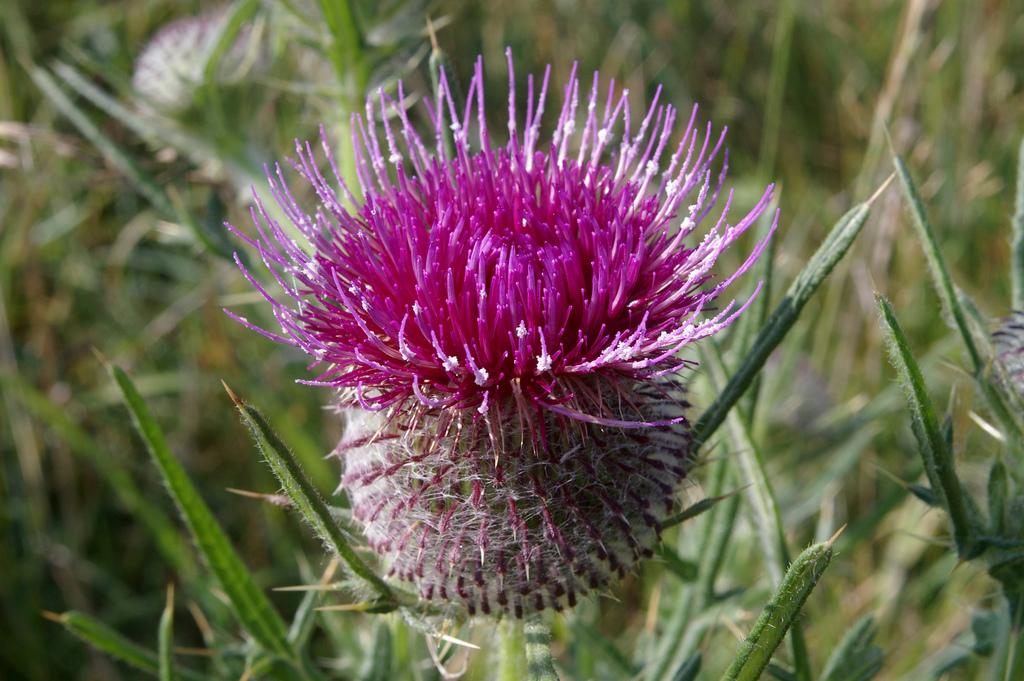What type of flower can be seen in the image? There is a pink color flower in the image. What stage of growth are the plants in the image at? There are buds on the plants in the image, indicating that they are in the process of blooming. What type of pies are being served on the pan in the image? There are: There is no pan or pies present in the image; it features a pink color flower and plants with buds. 